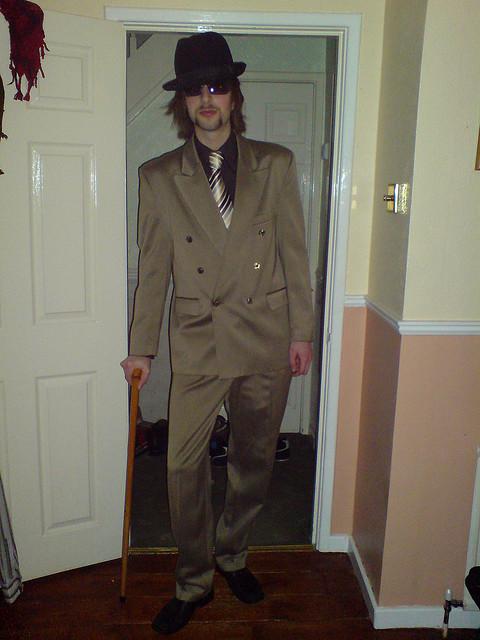What kind of pants is the man wearing?
Keep it brief. Suit. Is the man standing in the sun?
Keep it brief. No. What is on the floor beside the man?
Short answer required. Cane. What type of building is he standing in?
Answer briefly. House. How many men are in this photo?
Be succinct. 1. Is the man wearing a hat?
Be succinct. Yes. What has happened to the door?
Keep it brief. Opened. What color is the suit?
Answer briefly. Brown. Does the man have more hair on his face than on his head?
Quick response, please. No. Do you see the man's face?
Keep it brief. Yes. Is this man clean shaven?
Concise answer only. No. Does this person appear to need a cane due to old age?
Give a very brief answer. No. Is this person wearing a hat?
Write a very short answer. Yes. Is that a man?
Short answer required. Yes. What does this man have on his head?
Concise answer only. Hat. Is this a family picture?
Answer briefly. No. What branch is he?
Be succinct. Business. 